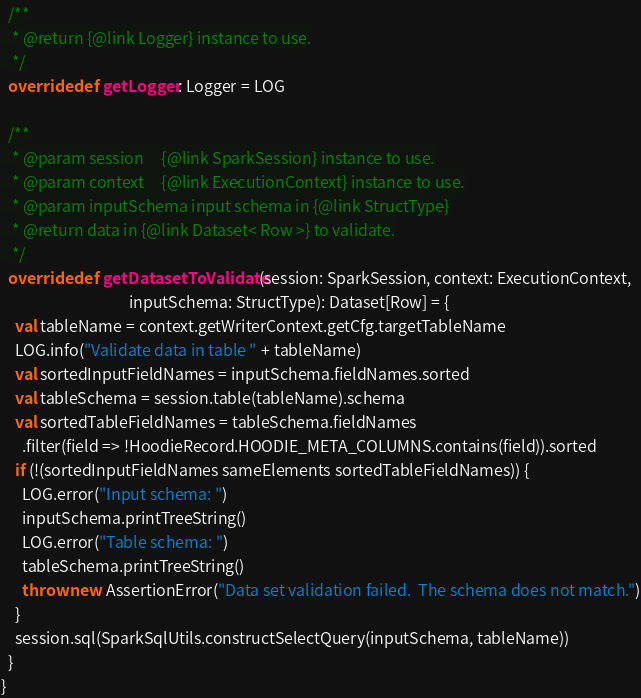<code> <loc_0><loc_0><loc_500><loc_500><_Scala_>
  /**
   * @return {@link Logger} instance to use.
   */
  override def getLogger: Logger = LOG

  /**
   * @param session     {@link SparkSession} instance to use.
   * @param context     {@link ExecutionContext} instance to use.
   * @param inputSchema input schema in {@link StructType}
   * @return data in {@link Dataset< Row >} to validate.
   */
  override def getDatasetToValidate(session: SparkSession, context: ExecutionContext,
                                    inputSchema: StructType): Dataset[Row] = {
    val tableName = context.getWriterContext.getCfg.targetTableName
    LOG.info("Validate data in table " + tableName)
    val sortedInputFieldNames = inputSchema.fieldNames.sorted
    val tableSchema = session.table(tableName).schema
    val sortedTableFieldNames = tableSchema.fieldNames
      .filter(field => !HoodieRecord.HOODIE_META_COLUMNS.contains(field)).sorted
    if (!(sortedInputFieldNames sameElements sortedTableFieldNames)) {
      LOG.error("Input schema: ")
      inputSchema.printTreeString()
      LOG.error("Table schema: ")
      tableSchema.printTreeString()
      throw new AssertionError("Data set validation failed.  The schema does not match.")
    }
    session.sql(SparkSqlUtils.constructSelectQuery(inputSchema, tableName))
  }
}
</code> 